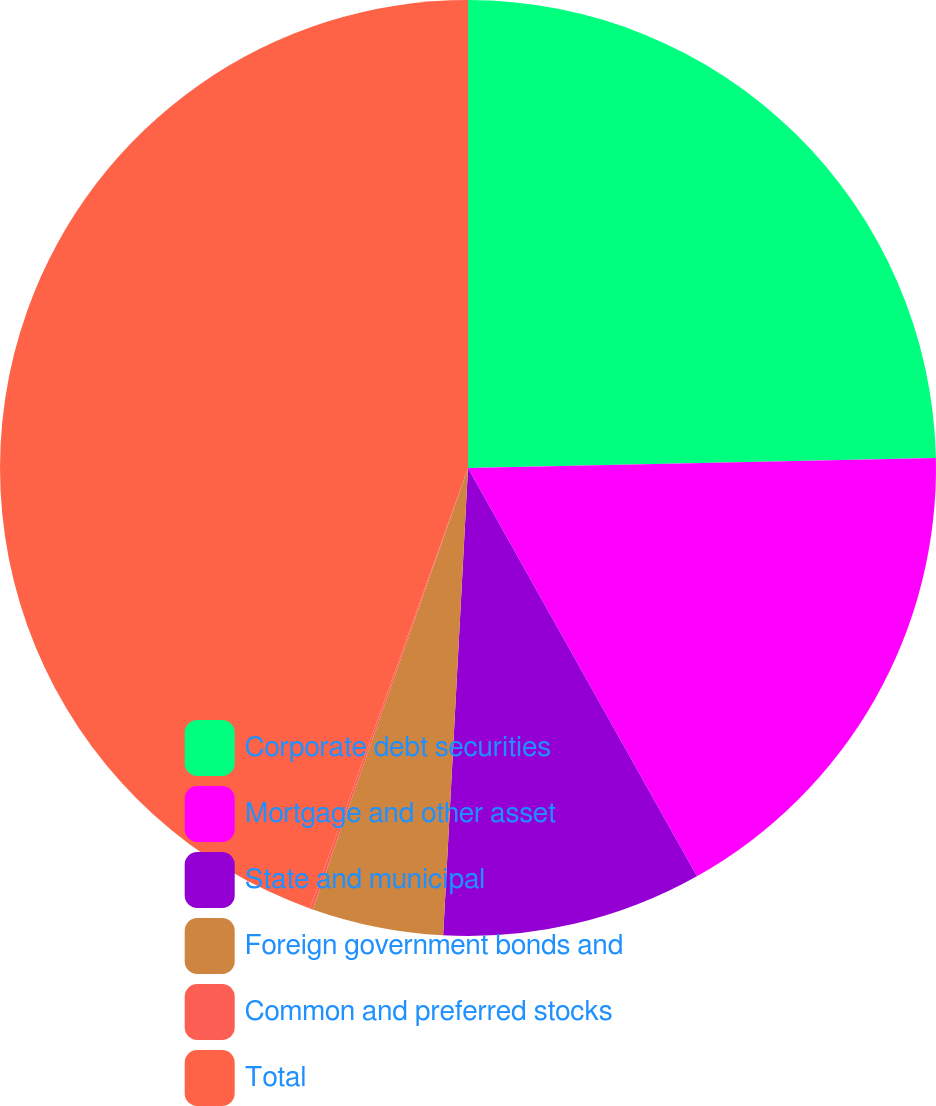<chart> <loc_0><loc_0><loc_500><loc_500><pie_chart><fcel>Corporate debt securities<fcel>Mortgage and other asset<fcel>State and municipal<fcel>Foreign government bonds and<fcel>Common and preferred stocks<fcel>Total<nl><fcel>24.66%<fcel>17.21%<fcel>8.98%<fcel>4.54%<fcel>0.1%<fcel>44.52%<nl></chart> 